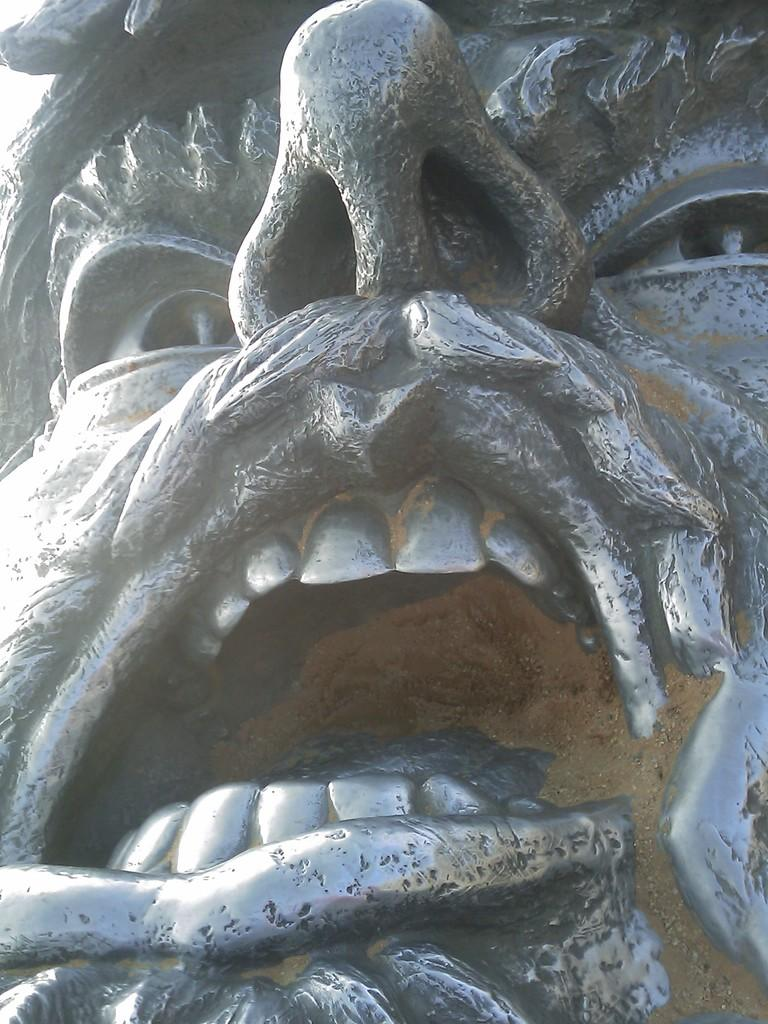What is the main subject of the image? There is a sculpture in the center of the image. Can you describe the sculpture in more detail? Unfortunately, the provided facts do not offer any additional details about the sculpture. Is there anything else visible in the image besides the sculpture? The provided facts do not mention any other objects or subjects in the image. What type of animals can be seen on the farm in the image? There is no farm present in the image; it features a sculpture as the main subject. What color is the chalk used to draw on the sidewalk in the image? There is no chalk or sidewalk present in the image; it features a sculpture as the main subject. 